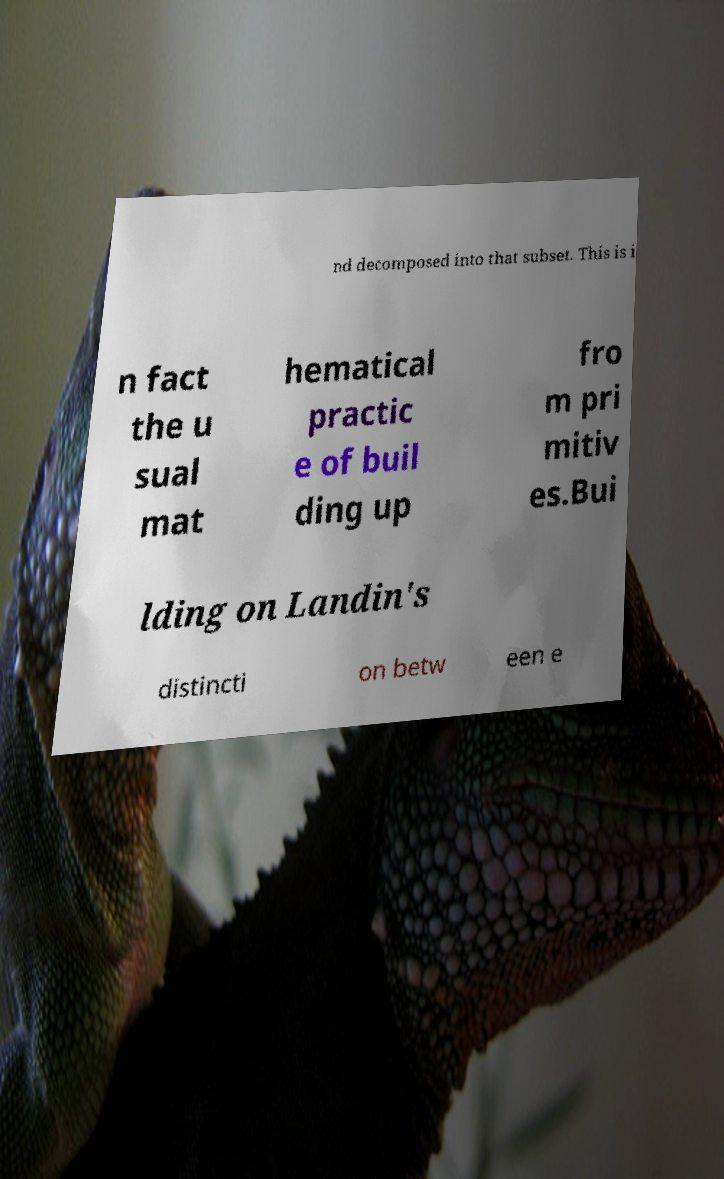There's text embedded in this image that I need extracted. Can you transcribe it verbatim? nd decomposed into that subset. This is i n fact the u sual mat hematical practic e of buil ding up fro m pri mitiv es.Bui lding on Landin's distincti on betw een e 